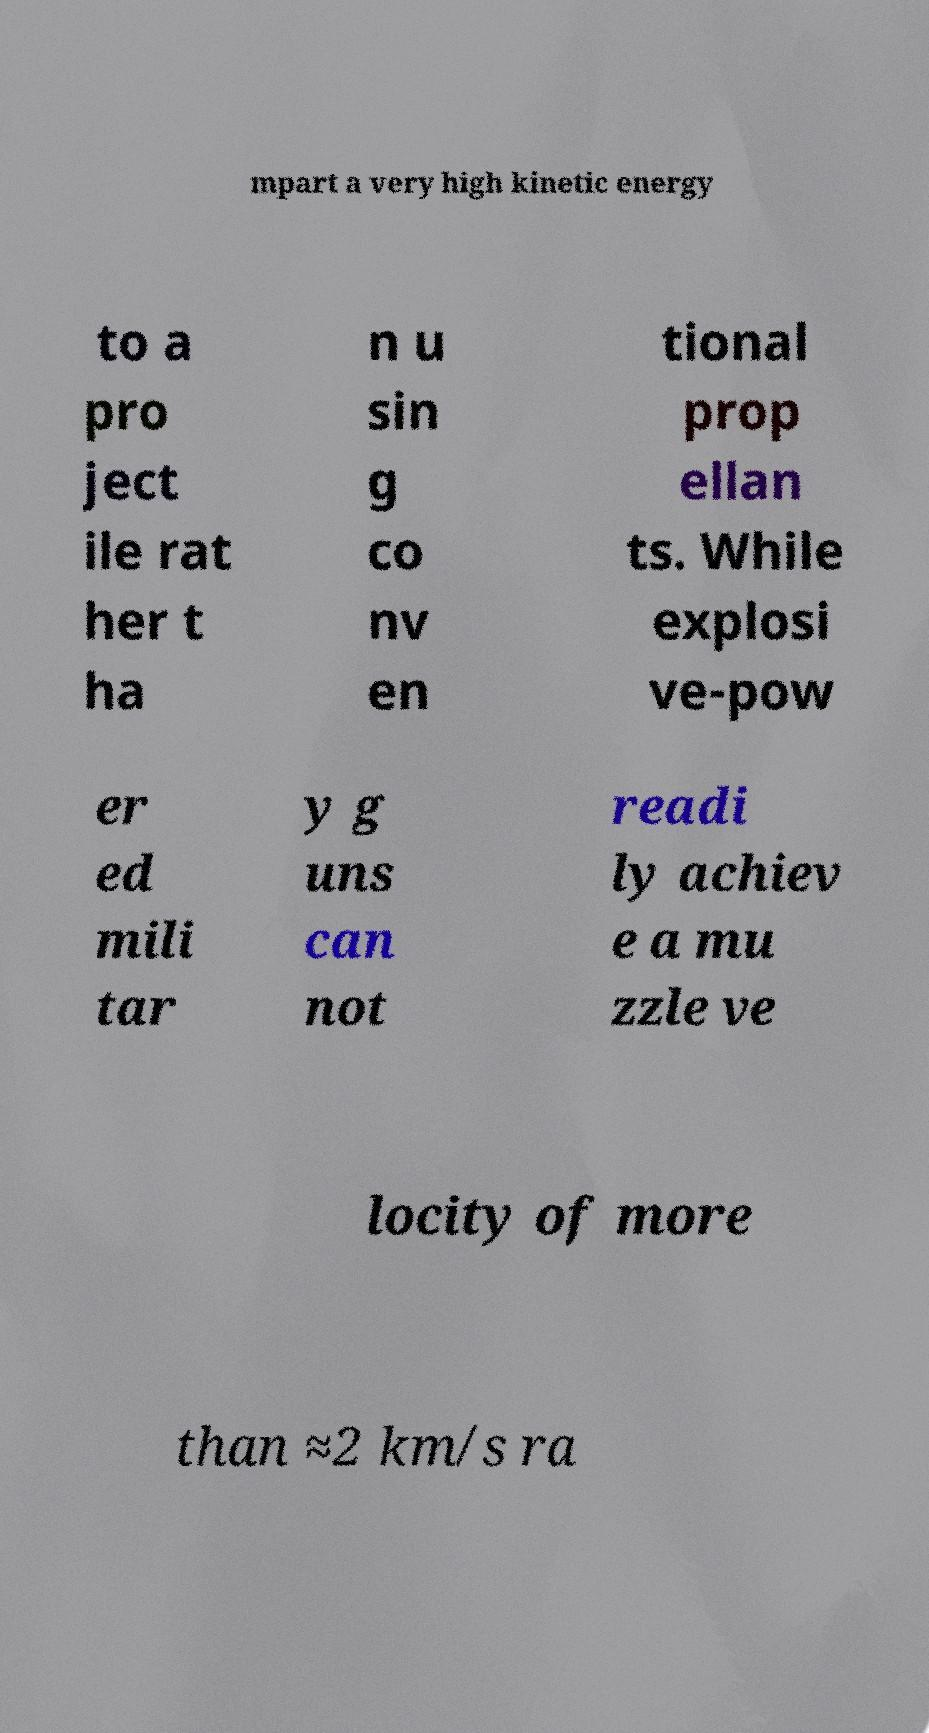Could you extract and type out the text from this image? mpart a very high kinetic energy to a pro ject ile rat her t ha n u sin g co nv en tional prop ellan ts. While explosi ve-pow er ed mili tar y g uns can not readi ly achiev e a mu zzle ve locity of more than ≈2 km/s ra 